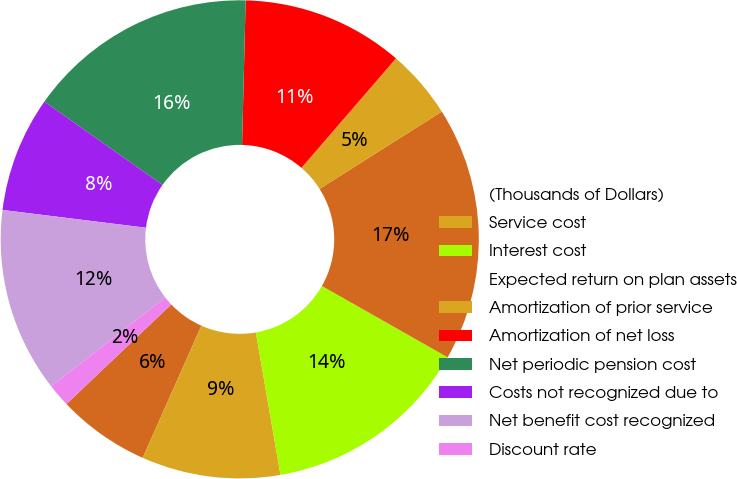<chart> <loc_0><loc_0><loc_500><loc_500><pie_chart><fcel>(Thousands of Dollars)<fcel>Service cost<fcel>Interest cost<fcel>Expected return on plan assets<fcel>Amortization of prior service<fcel>Amortization of net loss<fcel>Net periodic pension cost<fcel>Costs not recognized due to<fcel>Net benefit cost recognized<fcel>Discount rate<nl><fcel>6.25%<fcel>9.38%<fcel>14.06%<fcel>17.19%<fcel>4.69%<fcel>10.94%<fcel>15.62%<fcel>7.81%<fcel>12.5%<fcel>1.56%<nl></chart> 